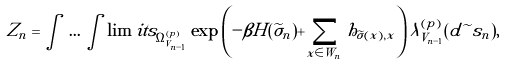Convert formula to latex. <formula><loc_0><loc_0><loc_500><loc_500>Z _ { n } = \int \, \dots \, \int \lim i t s _ { \Omega ^ { ( p ) } _ { V _ { n - 1 } } } \exp \left ( - \beta H ( { \widetilde { \sigma } } _ { n } ) + \sum _ { x \in W _ { n } } h _ { { \widetilde { \sigma } } ( x ) , x } \right ) \lambda ^ { ( p ) } _ { V _ { n - 1 } } ( { d \widetilde { \ } s _ { n } } ) ,</formula> 